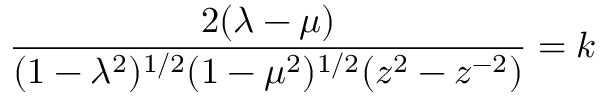<formula> <loc_0><loc_0><loc_500><loc_500>\frac { 2 ( \lambda - \mu ) } { ( 1 - \lambda ^ { 2 } ) ^ { 1 / 2 } ( 1 - \mu ^ { 2 } ) ^ { 1 / 2 } ( z ^ { 2 } - z ^ { - 2 } ) } = k</formula> 